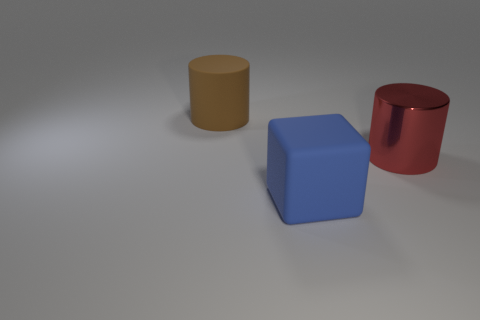Add 2 purple matte things. How many objects exist? 5 Subtract all cylinders. How many objects are left? 1 Subtract 0 purple blocks. How many objects are left? 3 Subtract all large gray metallic balls. Subtract all big blue rubber objects. How many objects are left? 2 Add 2 red cylinders. How many red cylinders are left? 3 Add 3 gray shiny objects. How many gray shiny objects exist? 3 